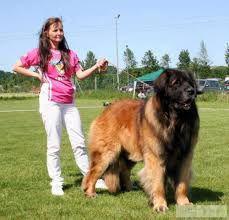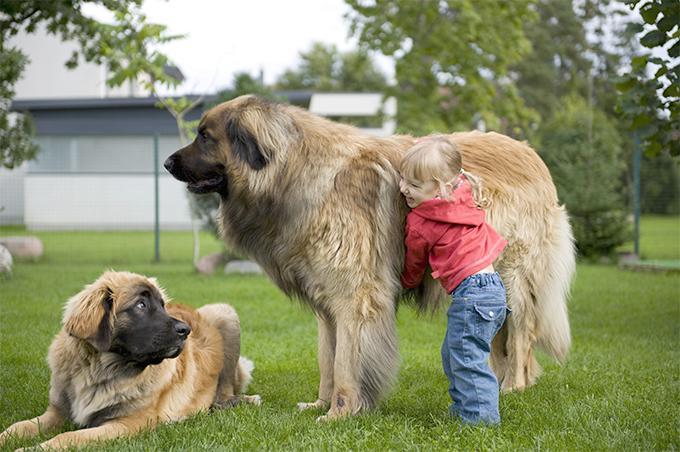The first image is the image on the left, the second image is the image on the right. Given the left and right images, does the statement "A little girl is holding a  large dog in the rightmost image." hold true? Answer yes or no. Yes. The first image is the image on the left, the second image is the image on the right. For the images displayed, is the sentence "There is one dog lying on the ground in the image on the right." factually correct? Answer yes or no. Yes. 